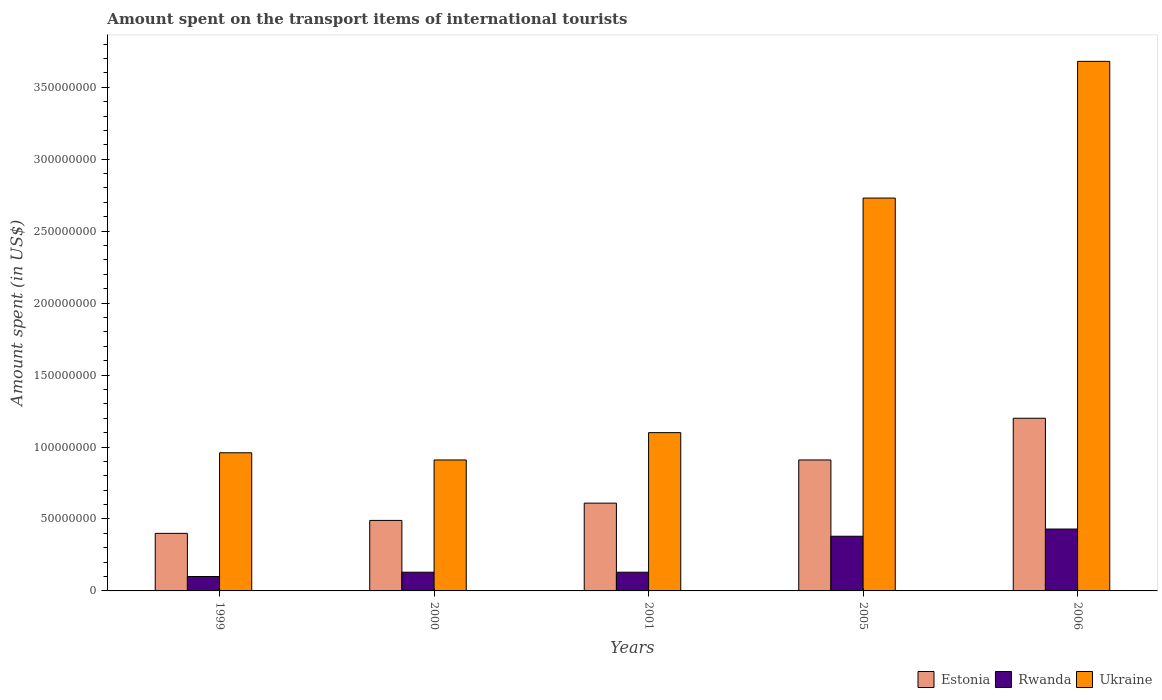Are the number of bars per tick equal to the number of legend labels?
Offer a very short reply. Yes. Are the number of bars on each tick of the X-axis equal?
Give a very brief answer. Yes. How many bars are there on the 5th tick from the left?
Ensure brevity in your answer.  3. What is the amount spent on the transport items of international tourists in Estonia in 2005?
Make the answer very short. 9.10e+07. Across all years, what is the maximum amount spent on the transport items of international tourists in Estonia?
Your answer should be very brief. 1.20e+08. Across all years, what is the minimum amount spent on the transport items of international tourists in Ukraine?
Offer a very short reply. 9.10e+07. In which year was the amount spent on the transport items of international tourists in Estonia maximum?
Provide a short and direct response. 2006. In which year was the amount spent on the transport items of international tourists in Estonia minimum?
Your answer should be very brief. 1999. What is the total amount spent on the transport items of international tourists in Rwanda in the graph?
Your answer should be compact. 1.17e+08. What is the difference between the amount spent on the transport items of international tourists in Ukraine in 2005 and that in 2006?
Your response must be concise. -9.50e+07. What is the difference between the amount spent on the transport items of international tourists in Ukraine in 2005 and the amount spent on the transport items of international tourists in Estonia in 2001?
Keep it short and to the point. 2.12e+08. What is the average amount spent on the transport items of international tourists in Estonia per year?
Give a very brief answer. 7.22e+07. In the year 2000, what is the difference between the amount spent on the transport items of international tourists in Ukraine and amount spent on the transport items of international tourists in Rwanda?
Give a very brief answer. 7.80e+07. What is the ratio of the amount spent on the transport items of international tourists in Rwanda in 2000 to that in 2005?
Your answer should be very brief. 0.34. Is the difference between the amount spent on the transport items of international tourists in Ukraine in 2001 and 2006 greater than the difference between the amount spent on the transport items of international tourists in Rwanda in 2001 and 2006?
Ensure brevity in your answer.  No. What is the difference between the highest and the second highest amount spent on the transport items of international tourists in Ukraine?
Provide a short and direct response. 9.50e+07. What is the difference between the highest and the lowest amount spent on the transport items of international tourists in Estonia?
Your response must be concise. 8.00e+07. In how many years, is the amount spent on the transport items of international tourists in Rwanda greater than the average amount spent on the transport items of international tourists in Rwanda taken over all years?
Give a very brief answer. 2. Is the sum of the amount spent on the transport items of international tourists in Estonia in 1999 and 2001 greater than the maximum amount spent on the transport items of international tourists in Ukraine across all years?
Provide a short and direct response. No. What does the 3rd bar from the left in 2000 represents?
Your answer should be very brief. Ukraine. What does the 2nd bar from the right in 1999 represents?
Your answer should be very brief. Rwanda. Is it the case that in every year, the sum of the amount spent on the transport items of international tourists in Rwanda and amount spent on the transport items of international tourists in Estonia is greater than the amount spent on the transport items of international tourists in Ukraine?
Your answer should be very brief. No. How many bars are there?
Provide a succinct answer. 15. Are all the bars in the graph horizontal?
Offer a very short reply. No. Where does the legend appear in the graph?
Give a very brief answer. Bottom right. How are the legend labels stacked?
Provide a succinct answer. Horizontal. What is the title of the graph?
Offer a terse response. Amount spent on the transport items of international tourists. What is the label or title of the X-axis?
Provide a succinct answer. Years. What is the label or title of the Y-axis?
Give a very brief answer. Amount spent (in US$). What is the Amount spent (in US$) in Estonia in 1999?
Offer a very short reply. 4.00e+07. What is the Amount spent (in US$) of Ukraine in 1999?
Provide a short and direct response. 9.60e+07. What is the Amount spent (in US$) of Estonia in 2000?
Your response must be concise. 4.90e+07. What is the Amount spent (in US$) in Rwanda in 2000?
Offer a very short reply. 1.30e+07. What is the Amount spent (in US$) of Ukraine in 2000?
Make the answer very short. 9.10e+07. What is the Amount spent (in US$) of Estonia in 2001?
Make the answer very short. 6.10e+07. What is the Amount spent (in US$) in Rwanda in 2001?
Your answer should be compact. 1.30e+07. What is the Amount spent (in US$) in Ukraine in 2001?
Ensure brevity in your answer.  1.10e+08. What is the Amount spent (in US$) in Estonia in 2005?
Offer a terse response. 9.10e+07. What is the Amount spent (in US$) in Rwanda in 2005?
Give a very brief answer. 3.80e+07. What is the Amount spent (in US$) in Ukraine in 2005?
Make the answer very short. 2.73e+08. What is the Amount spent (in US$) in Estonia in 2006?
Give a very brief answer. 1.20e+08. What is the Amount spent (in US$) of Rwanda in 2006?
Keep it short and to the point. 4.30e+07. What is the Amount spent (in US$) of Ukraine in 2006?
Ensure brevity in your answer.  3.68e+08. Across all years, what is the maximum Amount spent (in US$) of Estonia?
Provide a succinct answer. 1.20e+08. Across all years, what is the maximum Amount spent (in US$) of Rwanda?
Your answer should be very brief. 4.30e+07. Across all years, what is the maximum Amount spent (in US$) of Ukraine?
Ensure brevity in your answer.  3.68e+08. Across all years, what is the minimum Amount spent (in US$) of Estonia?
Offer a terse response. 4.00e+07. Across all years, what is the minimum Amount spent (in US$) in Rwanda?
Provide a short and direct response. 1.00e+07. Across all years, what is the minimum Amount spent (in US$) in Ukraine?
Your response must be concise. 9.10e+07. What is the total Amount spent (in US$) of Estonia in the graph?
Keep it short and to the point. 3.61e+08. What is the total Amount spent (in US$) of Rwanda in the graph?
Make the answer very short. 1.17e+08. What is the total Amount spent (in US$) of Ukraine in the graph?
Give a very brief answer. 9.38e+08. What is the difference between the Amount spent (in US$) in Estonia in 1999 and that in 2000?
Give a very brief answer. -9.00e+06. What is the difference between the Amount spent (in US$) in Rwanda in 1999 and that in 2000?
Give a very brief answer. -3.00e+06. What is the difference between the Amount spent (in US$) of Estonia in 1999 and that in 2001?
Your response must be concise. -2.10e+07. What is the difference between the Amount spent (in US$) of Rwanda in 1999 and that in 2001?
Keep it short and to the point. -3.00e+06. What is the difference between the Amount spent (in US$) in Ukraine in 1999 and that in 2001?
Make the answer very short. -1.40e+07. What is the difference between the Amount spent (in US$) of Estonia in 1999 and that in 2005?
Keep it short and to the point. -5.10e+07. What is the difference between the Amount spent (in US$) of Rwanda in 1999 and that in 2005?
Your answer should be compact. -2.80e+07. What is the difference between the Amount spent (in US$) in Ukraine in 1999 and that in 2005?
Provide a short and direct response. -1.77e+08. What is the difference between the Amount spent (in US$) of Estonia in 1999 and that in 2006?
Provide a short and direct response. -8.00e+07. What is the difference between the Amount spent (in US$) of Rwanda in 1999 and that in 2006?
Offer a terse response. -3.30e+07. What is the difference between the Amount spent (in US$) of Ukraine in 1999 and that in 2006?
Give a very brief answer. -2.72e+08. What is the difference between the Amount spent (in US$) in Estonia in 2000 and that in 2001?
Ensure brevity in your answer.  -1.20e+07. What is the difference between the Amount spent (in US$) of Rwanda in 2000 and that in 2001?
Make the answer very short. 0. What is the difference between the Amount spent (in US$) in Ukraine in 2000 and that in 2001?
Keep it short and to the point. -1.90e+07. What is the difference between the Amount spent (in US$) of Estonia in 2000 and that in 2005?
Ensure brevity in your answer.  -4.20e+07. What is the difference between the Amount spent (in US$) in Rwanda in 2000 and that in 2005?
Offer a terse response. -2.50e+07. What is the difference between the Amount spent (in US$) of Ukraine in 2000 and that in 2005?
Offer a terse response. -1.82e+08. What is the difference between the Amount spent (in US$) in Estonia in 2000 and that in 2006?
Offer a very short reply. -7.10e+07. What is the difference between the Amount spent (in US$) of Rwanda in 2000 and that in 2006?
Your answer should be very brief. -3.00e+07. What is the difference between the Amount spent (in US$) in Ukraine in 2000 and that in 2006?
Offer a terse response. -2.77e+08. What is the difference between the Amount spent (in US$) of Estonia in 2001 and that in 2005?
Provide a short and direct response. -3.00e+07. What is the difference between the Amount spent (in US$) of Rwanda in 2001 and that in 2005?
Provide a succinct answer. -2.50e+07. What is the difference between the Amount spent (in US$) in Ukraine in 2001 and that in 2005?
Give a very brief answer. -1.63e+08. What is the difference between the Amount spent (in US$) in Estonia in 2001 and that in 2006?
Keep it short and to the point. -5.90e+07. What is the difference between the Amount spent (in US$) in Rwanda in 2001 and that in 2006?
Provide a succinct answer. -3.00e+07. What is the difference between the Amount spent (in US$) in Ukraine in 2001 and that in 2006?
Provide a short and direct response. -2.58e+08. What is the difference between the Amount spent (in US$) in Estonia in 2005 and that in 2006?
Offer a very short reply. -2.90e+07. What is the difference between the Amount spent (in US$) in Rwanda in 2005 and that in 2006?
Give a very brief answer. -5.00e+06. What is the difference between the Amount spent (in US$) in Ukraine in 2005 and that in 2006?
Provide a short and direct response. -9.50e+07. What is the difference between the Amount spent (in US$) of Estonia in 1999 and the Amount spent (in US$) of Rwanda in 2000?
Give a very brief answer. 2.70e+07. What is the difference between the Amount spent (in US$) of Estonia in 1999 and the Amount spent (in US$) of Ukraine in 2000?
Your response must be concise. -5.10e+07. What is the difference between the Amount spent (in US$) of Rwanda in 1999 and the Amount spent (in US$) of Ukraine in 2000?
Your response must be concise. -8.10e+07. What is the difference between the Amount spent (in US$) of Estonia in 1999 and the Amount spent (in US$) of Rwanda in 2001?
Offer a terse response. 2.70e+07. What is the difference between the Amount spent (in US$) in Estonia in 1999 and the Amount spent (in US$) in Ukraine in 2001?
Provide a succinct answer. -7.00e+07. What is the difference between the Amount spent (in US$) in Rwanda in 1999 and the Amount spent (in US$) in Ukraine in 2001?
Ensure brevity in your answer.  -1.00e+08. What is the difference between the Amount spent (in US$) of Estonia in 1999 and the Amount spent (in US$) of Rwanda in 2005?
Your answer should be very brief. 2.00e+06. What is the difference between the Amount spent (in US$) in Estonia in 1999 and the Amount spent (in US$) in Ukraine in 2005?
Ensure brevity in your answer.  -2.33e+08. What is the difference between the Amount spent (in US$) of Rwanda in 1999 and the Amount spent (in US$) of Ukraine in 2005?
Provide a short and direct response. -2.63e+08. What is the difference between the Amount spent (in US$) in Estonia in 1999 and the Amount spent (in US$) in Ukraine in 2006?
Ensure brevity in your answer.  -3.28e+08. What is the difference between the Amount spent (in US$) of Rwanda in 1999 and the Amount spent (in US$) of Ukraine in 2006?
Keep it short and to the point. -3.58e+08. What is the difference between the Amount spent (in US$) of Estonia in 2000 and the Amount spent (in US$) of Rwanda in 2001?
Your response must be concise. 3.60e+07. What is the difference between the Amount spent (in US$) of Estonia in 2000 and the Amount spent (in US$) of Ukraine in 2001?
Offer a very short reply. -6.10e+07. What is the difference between the Amount spent (in US$) in Rwanda in 2000 and the Amount spent (in US$) in Ukraine in 2001?
Your answer should be compact. -9.70e+07. What is the difference between the Amount spent (in US$) of Estonia in 2000 and the Amount spent (in US$) of Rwanda in 2005?
Offer a very short reply. 1.10e+07. What is the difference between the Amount spent (in US$) of Estonia in 2000 and the Amount spent (in US$) of Ukraine in 2005?
Your answer should be very brief. -2.24e+08. What is the difference between the Amount spent (in US$) in Rwanda in 2000 and the Amount spent (in US$) in Ukraine in 2005?
Your answer should be very brief. -2.60e+08. What is the difference between the Amount spent (in US$) of Estonia in 2000 and the Amount spent (in US$) of Rwanda in 2006?
Your response must be concise. 6.00e+06. What is the difference between the Amount spent (in US$) in Estonia in 2000 and the Amount spent (in US$) in Ukraine in 2006?
Provide a short and direct response. -3.19e+08. What is the difference between the Amount spent (in US$) of Rwanda in 2000 and the Amount spent (in US$) of Ukraine in 2006?
Your response must be concise. -3.55e+08. What is the difference between the Amount spent (in US$) in Estonia in 2001 and the Amount spent (in US$) in Rwanda in 2005?
Give a very brief answer. 2.30e+07. What is the difference between the Amount spent (in US$) of Estonia in 2001 and the Amount spent (in US$) of Ukraine in 2005?
Provide a succinct answer. -2.12e+08. What is the difference between the Amount spent (in US$) in Rwanda in 2001 and the Amount spent (in US$) in Ukraine in 2005?
Keep it short and to the point. -2.60e+08. What is the difference between the Amount spent (in US$) in Estonia in 2001 and the Amount spent (in US$) in Rwanda in 2006?
Offer a terse response. 1.80e+07. What is the difference between the Amount spent (in US$) in Estonia in 2001 and the Amount spent (in US$) in Ukraine in 2006?
Provide a succinct answer. -3.07e+08. What is the difference between the Amount spent (in US$) in Rwanda in 2001 and the Amount spent (in US$) in Ukraine in 2006?
Make the answer very short. -3.55e+08. What is the difference between the Amount spent (in US$) in Estonia in 2005 and the Amount spent (in US$) in Rwanda in 2006?
Make the answer very short. 4.80e+07. What is the difference between the Amount spent (in US$) of Estonia in 2005 and the Amount spent (in US$) of Ukraine in 2006?
Your answer should be compact. -2.77e+08. What is the difference between the Amount spent (in US$) in Rwanda in 2005 and the Amount spent (in US$) in Ukraine in 2006?
Keep it short and to the point. -3.30e+08. What is the average Amount spent (in US$) in Estonia per year?
Your answer should be very brief. 7.22e+07. What is the average Amount spent (in US$) of Rwanda per year?
Your response must be concise. 2.34e+07. What is the average Amount spent (in US$) in Ukraine per year?
Offer a very short reply. 1.88e+08. In the year 1999, what is the difference between the Amount spent (in US$) of Estonia and Amount spent (in US$) of Rwanda?
Your response must be concise. 3.00e+07. In the year 1999, what is the difference between the Amount spent (in US$) in Estonia and Amount spent (in US$) in Ukraine?
Ensure brevity in your answer.  -5.60e+07. In the year 1999, what is the difference between the Amount spent (in US$) in Rwanda and Amount spent (in US$) in Ukraine?
Provide a succinct answer. -8.60e+07. In the year 2000, what is the difference between the Amount spent (in US$) in Estonia and Amount spent (in US$) in Rwanda?
Offer a very short reply. 3.60e+07. In the year 2000, what is the difference between the Amount spent (in US$) of Estonia and Amount spent (in US$) of Ukraine?
Offer a terse response. -4.20e+07. In the year 2000, what is the difference between the Amount spent (in US$) of Rwanda and Amount spent (in US$) of Ukraine?
Your answer should be compact. -7.80e+07. In the year 2001, what is the difference between the Amount spent (in US$) in Estonia and Amount spent (in US$) in Rwanda?
Keep it short and to the point. 4.80e+07. In the year 2001, what is the difference between the Amount spent (in US$) in Estonia and Amount spent (in US$) in Ukraine?
Offer a very short reply. -4.90e+07. In the year 2001, what is the difference between the Amount spent (in US$) in Rwanda and Amount spent (in US$) in Ukraine?
Your answer should be very brief. -9.70e+07. In the year 2005, what is the difference between the Amount spent (in US$) in Estonia and Amount spent (in US$) in Rwanda?
Make the answer very short. 5.30e+07. In the year 2005, what is the difference between the Amount spent (in US$) in Estonia and Amount spent (in US$) in Ukraine?
Keep it short and to the point. -1.82e+08. In the year 2005, what is the difference between the Amount spent (in US$) in Rwanda and Amount spent (in US$) in Ukraine?
Keep it short and to the point. -2.35e+08. In the year 2006, what is the difference between the Amount spent (in US$) in Estonia and Amount spent (in US$) in Rwanda?
Make the answer very short. 7.70e+07. In the year 2006, what is the difference between the Amount spent (in US$) in Estonia and Amount spent (in US$) in Ukraine?
Provide a succinct answer. -2.48e+08. In the year 2006, what is the difference between the Amount spent (in US$) in Rwanda and Amount spent (in US$) in Ukraine?
Offer a terse response. -3.25e+08. What is the ratio of the Amount spent (in US$) in Estonia in 1999 to that in 2000?
Your answer should be very brief. 0.82. What is the ratio of the Amount spent (in US$) in Rwanda in 1999 to that in 2000?
Provide a succinct answer. 0.77. What is the ratio of the Amount spent (in US$) in Ukraine in 1999 to that in 2000?
Offer a terse response. 1.05. What is the ratio of the Amount spent (in US$) in Estonia in 1999 to that in 2001?
Keep it short and to the point. 0.66. What is the ratio of the Amount spent (in US$) of Rwanda in 1999 to that in 2001?
Ensure brevity in your answer.  0.77. What is the ratio of the Amount spent (in US$) in Ukraine in 1999 to that in 2001?
Your answer should be very brief. 0.87. What is the ratio of the Amount spent (in US$) of Estonia in 1999 to that in 2005?
Your response must be concise. 0.44. What is the ratio of the Amount spent (in US$) in Rwanda in 1999 to that in 2005?
Keep it short and to the point. 0.26. What is the ratio of the Amount spent (in US$) in Ukraine in 1999 to that in 2005?
Provide a short and direct response. 0.35. What is the ratio of the Amount spent (in US$) in Rwanda in 1999 to that in 2006?
Provide a succinct answer. 0.23. What is the ratio of the Amount spent (in US$) in Ukraine in 1999 to that in 2006?
Ensure brevity in your answer.  0.26. What is the ratio of the Amount spent (in US$) of Estonia in 2000 to that in 2001?
Your answer should be compact. 0.8. What is the ratio of the Amount spent (in US$) in Rwanda in 2000 to that in 2001?
Your response must be concise. 1. What is the ratio of the Amount spent (in US$) in Ukraine in 2000 to that in 2001?
Ensure brevity in your answer.  0.83. What is the ratio of the Amount spent (in US$) of Estonia in 2000 to that in 2005?
Your answer should be very brief. 0.54. What is the ratio of the Amount spent (in US$) of Rwanda in 2000 to that in 2005?
Provide a succinct answer. 0.34. What is the ratio of the Amount spent (in US$) in Estonia in 2000 to that in 2006?
Offer a very short reply. 0.41. What is the ratio of the Amount spent (in US$) of Rwanda in 2000 to that in 2006?
Your response must be concise. 0.3. What is the ratio of the Amount spent (in US$) of Ukraine in 2000 to that in 2006?
Ensure brevity in your answer.  0.25. What is the ratio of the Amount spent (in US$) of Estonia in 2001 to that in 2005?
Your answer should be compact. 0.67. What is the ratio of the Amount spent (in US$) of Rwanda in 2001 to that in 2005?
Keep it short and to the point. 0.34. What is the ratio of the Amount spent (in US$) of Ukraine in 2001 to that in 2005?
Your response must be concise. 0.4. What is the ratio of the Amount spent (in US$) of Estonia in 2001 to that in 2006?
Make the answer very short. 0.51. What is the ratio of the Amount spent (in US$) of Rwanda in 2001 to that in 2006?
Ensure brevity in your answer.  0.3. What is the ratio of the Amount spent (in US$) of Ukraine in 2001 to that in 2006?
Offer a very short reply. 0.3. What is the ratio of the Amount spent (in US$) of Estonia in 2005 to that in 2006?
Offer a terse response. 0.76. What is the ratio of the Amount spent (in US$) in Rwanda in 2005 to that in 2006?
Provide a succinct answer. 0.88. What is the ratio of the Amount spent (in US$) in Ukraine in 2005 to that in 2006?
Your answer should be very brief. 0.74. What is the difference between the highest and the second highest Amount spent (in US$) of Estonia?
Offer a terse response. 2.90e+07. What is the difference between the highest and the second highest Amount spent (in US$) in Ukraine?
Offer a terse response. 9.50e+07. What is the difference between the highest and the lowest Amount spent (in US$) of Estonia?
Your response must be concise. 8.00e+07. What is the difference between the highest and the lowest Amount spent (in US$) of Rwanda?
Your answer should be compact. 3.30e+07. What is the difference between the highest and the lowest Amount spent (in US$) in Ukraine?
Provide a short and direct response. 2.77e+08. 